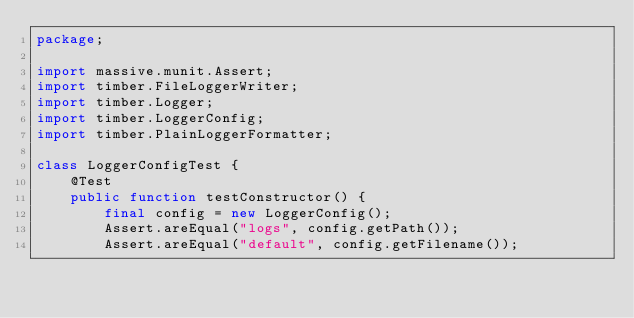Convert code to text. <code><loc_0><loc_0><loc_500><loc_500><_Haxe_>package;

import massive.munit.Assert;
import timber.FileLoggerWriter;
import timber.Logger;
import timber.LoggerConfig;
import timber.PlainLoggerFormatter;

class LoggerConfigTest {
	@Test
	public function testConstructor() {
        final config = new LoggerConfig();
		Assert.areEqual("logs", config.getPath());
        Assert.areEqual("default", config.getFilename());</code> 